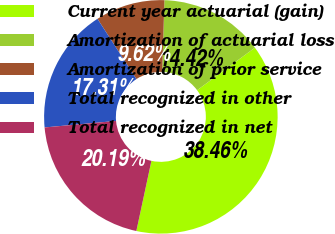Convert chart. <chart><loc_0><loc_0><loc_500><loc_500><pie_chart><fcel>Current year actuarial (gain)<fcel>Amortization of actuarial loss<fcel>Amortization of prior service<fcel>Total recognized in other<fcel>Total recognized in net<nl><fcel>38.46%<fcel>14.42%<fcel>9.62%<fcel>17.31%<fcel>20.19%<nl></chart> 